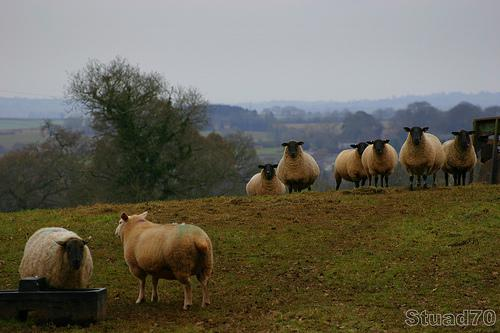Question: where was the picture taken?
Choices:
A. On a mountain.
B. In a taxi.
C. In a field.
D. In a bedroom.
Answer with the letter. Answer: C Question: who is with the sheep?
Choices:
A. Shepherd.
B. Man.
C. No one.
D. Woman.
Answer with the letter. Answer: C Question: what has been written on the pic?
Choices:
A. 6/19/15.
B. Stuad70.
C. A name.
D. Confidential.
Answer with the letter. Answer: B Question: why are they standing?
Choices:
A. Looking at the water.
B. Near the docks.
C. Looking at the camera.
D. In the bedroom.
Answer with the letter. Answer: C Question: how many are near the camera?
Choices:
A. 3.
B. 2.
C. 4.
D. 5.
Answer with the letter. Answer: B Question: when was the picture taken?
Choices:
A. At night.
B. 3pm.
C. Before the graduation party.
D. During the day.
Answer with the letter. Answer: D Question: what is near the two animals?
Choices:
A. Food box.
B. Water bowl.
C. A tree.
D. A child.
Answer with the letter. Answer: A 